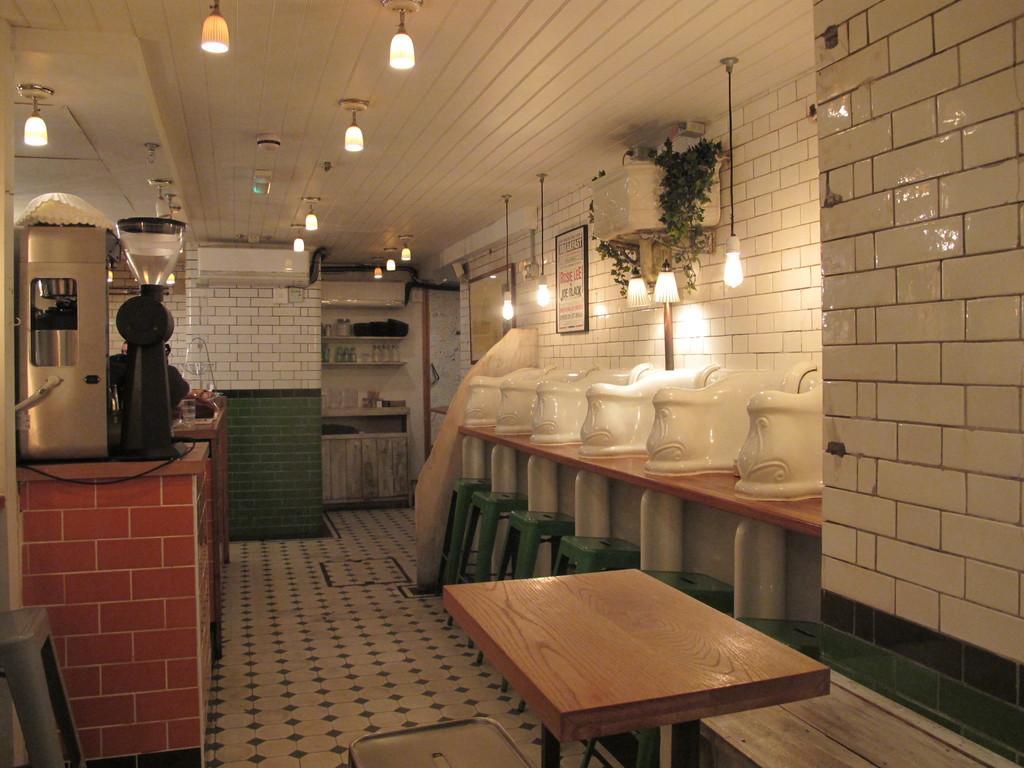How would you summarize this image in a sentence or two? In this there is a table at the bottom side of the image and there are lamps at the top side of the image and there is a vending machine on the left side of the image, there are stools in series on the right side of the image. 